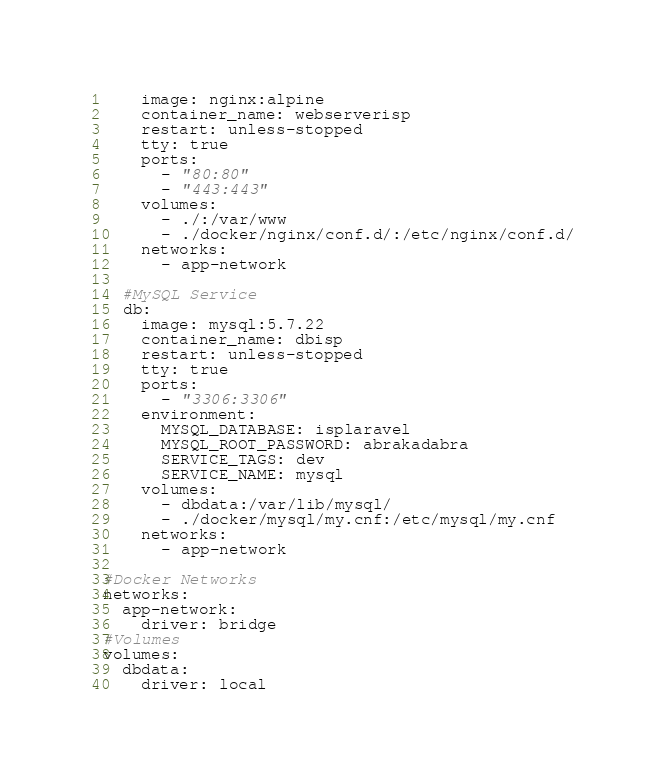Convert code to text. <code><loc_0><loc_0><loc_500><loc_500><_YAML_>    image: nginx:alpine
    container_name: webserverisp
    restart: unless-stopped
    tty: true
    ports:
      - "80:80"
      - "443:443"
    volumes:
      - ./:/var/www
      - ./docker/nginx/conf.d/:/etc/nginx/conf.d/
    networks:
      - app-network

  #MySQL Service
  db:
    image: mysql:5.7.22
    container_name: dbisp
    restart: unless-stopped
    tty: true
    ports:
      - "3306:3306"
    environment:
      MYSQL_DATABASE: isplaravel
      MYSQL_ROOT_PASSWORD: abrakadabra
      SERVICE_TAGS: dev
      SERVICE_NAME: mysql
    volumes:
      - dbdata:/var/lib/mysql/
      - ./docker/mysql/my.cnf:/etc/mysql/my.cnf
    networks:
      - app-network

#Docker Networks
networks:
  app-network:
    driver: bridge
#Volumes
volumes:
  dbdata:
    driver: local
</code> 